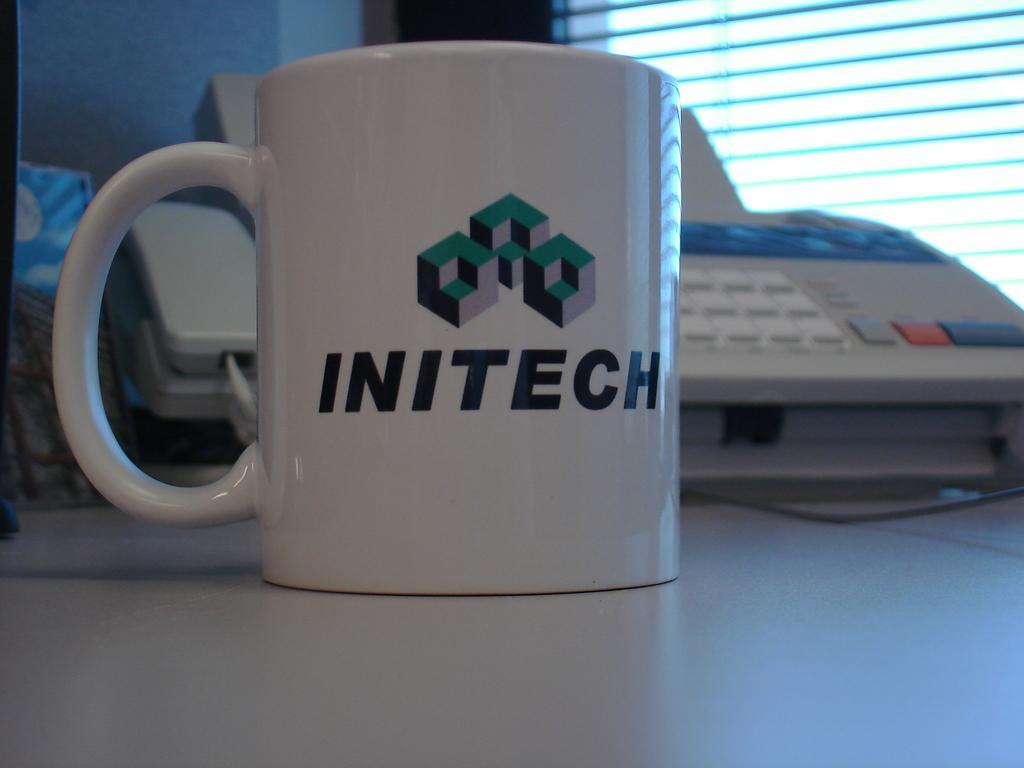Please provide a concise description of this image. As we can see in the image there is a table, keyboard, cup and a window. 